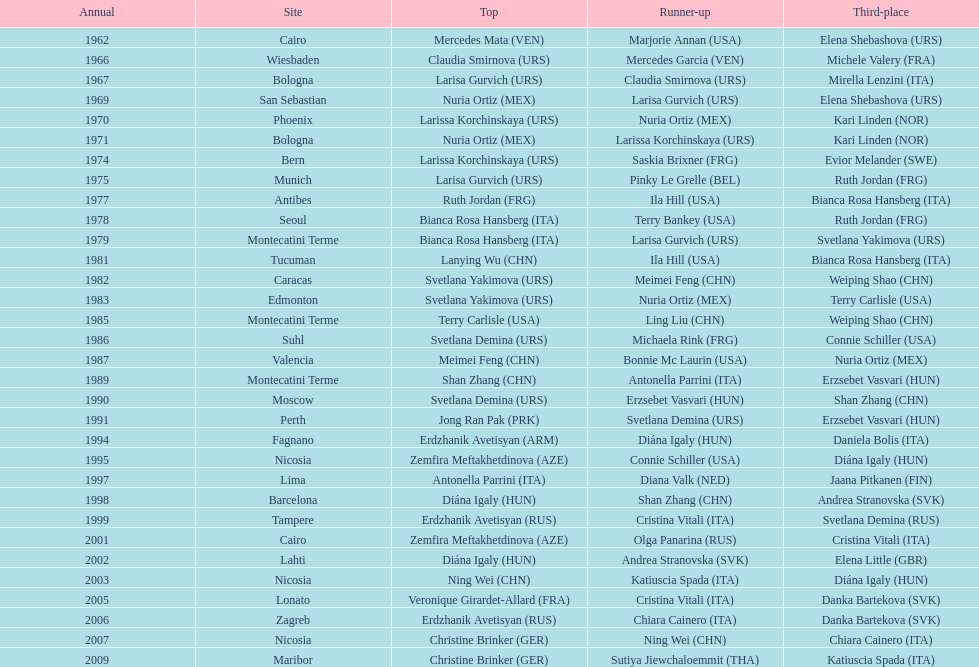Who won the only gold medal in 1962? Mercedes Mata. 